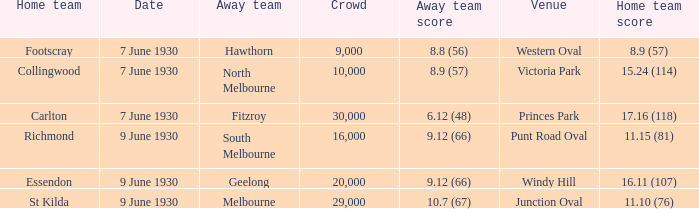What is the mean attendance for hawthorn matches as the away team? 9000.0. 